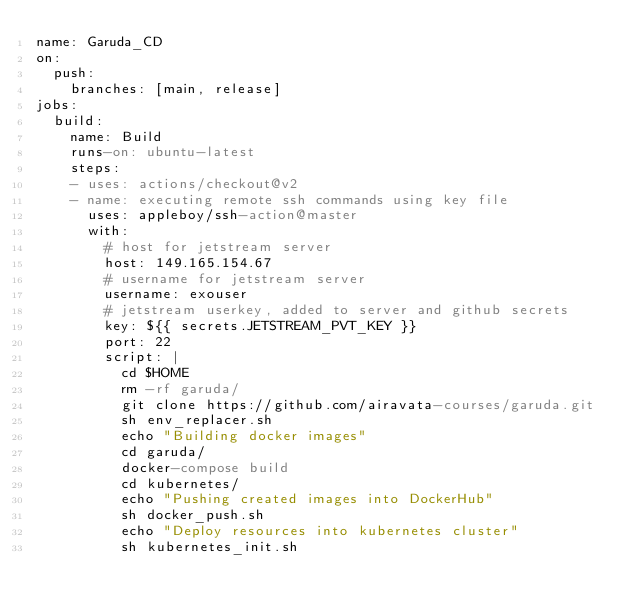<code> <loc_0><loc_0><loc_500><loc_500><_YAML_>name: Garuda_CD
on:
  push:
    branches: [main, release]
jobs:
  build:
    name: Build
    runs-on: ubuntu-latest
    steps:
    - uses: actions/checkout@v2
    - name: executing remote ssh commands using key file
      uses: appleboy/ssh-action@master
      with:
        # host for jetstream server
        host: 149.165.154.67
        # username for jetstream server
        username: exouser
        # jetstream userkey, added to server and github secrets
        key: ${{ secrets.JETSTREAM_PVT_KEY }}
        port: 22
        script: |
          cd $HOME
          rm -rf garuda/
          git clone https://github.com/airavata-courses/garuda.git
          sh env_replacer.sh
          echo "Building docker images"
          cd garuda/
          docker-compose build
          cd kubernetes/
          echo "Pushing created images into DockerHub"
          sh docker_push.sh
          echo "Deploy resources into kubernetes cluster"
          sh kubernetes_init.sh</code> 